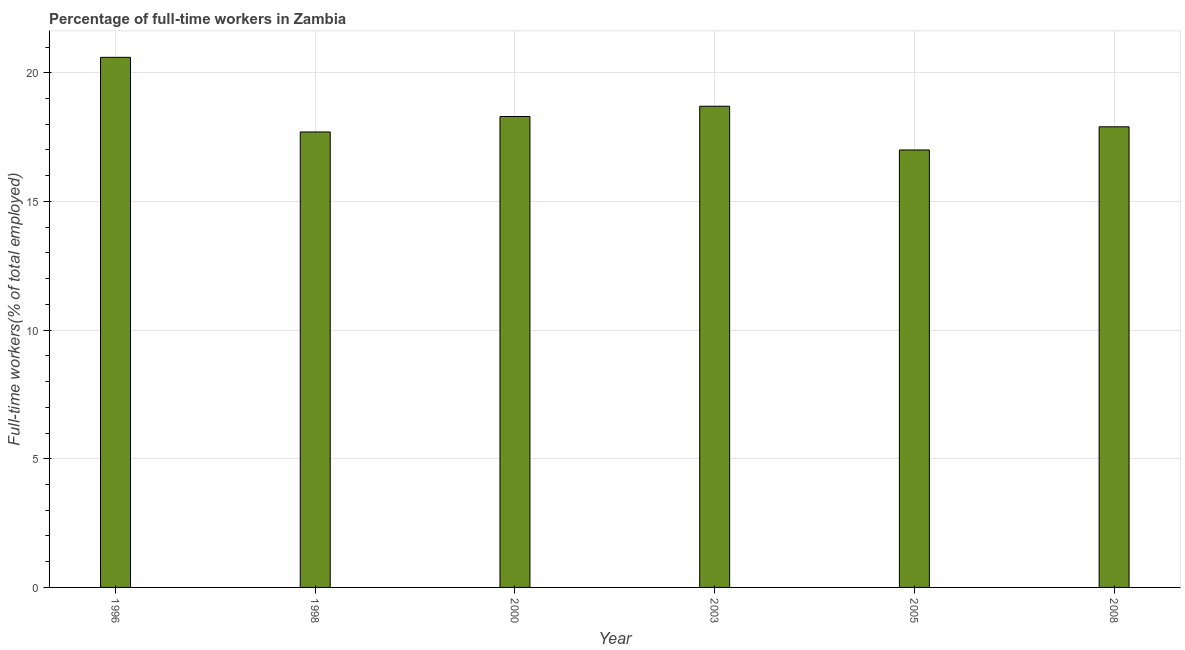Does the graph contain grids?
Ensure brevity in your answer.  Yes. What is the title of the graph?
Ensure brevity in your answer.  Percentage of full-time workers in Zambia. What is the label or title of the Y-axis?
Offer a terse response. Full-time workers(% of total employed). What is the percentage of full-time workers in 2000?
Your answer should be compact. 18.3. Across all years, what is the maximum percentage of full-time workers?
Give a very brief answer. 20.6. What is the sum of the percentage of full-time workers?
Provide a succinct answer. 110.2. What is the average percentage of full-time workers per year?
Offer a terse response. 18.37. What is the median percentage of full-time workers?
Make the answer very short. 18.1. Is the percentage of full-time workers in 1998 less than that in 2008?
Provide a succinct answer. Yes. Is the difference between the percentage of full-time workers in 1998 and 2005 greater than the difference between any two years?
Your response must be concise. No. What is the difference between the highest and the lowest percentage of full-time workers?
Ensure brevity in your answer.  3.6. How many years are there in the graph?
Ensure brevity in your answer.  6. What is the Full-time workers(% of total employed) of 1996?
Make the answer very short. 20.6. What is the Full-time workers(% of total employed) in 1998?
Your response must be concise. 17.7. What is the Full-time workers(% of total employed) in 2000?
Make the answer very short. 18.3. What is the Full-time workers(% of total employed) in 2003?
Provide a short and direct response. 18.7. What is the Full-time workers(% of total employed) of 2005?
Offer a very short reply. 17. What is the Full-time workers(% of total employed) in 2008?
Offer a very short reply. 17.9. What is the difference between the Full-time workers(% of total employed) in 1996 and 2000?
Provide a short and direct response. 2.3. What is the difference between the Full-time workers(% of total employed) in 1996 and 2008?
Make the answer very short. 2.7. What is the difference between the Full-time workers(% of total employed) in 1998 and 2000?
Provide a succinct answer. -0.6. What is the difference between the Full-time workers(% of total employed) in 1998 and 2003?
Provide a short and direct response. -1. What is the difference between the Full-time workers(% of total employed) in 1998 and 2005?
Provide a short and direct response. 0.7. What is the difference between the Full-time workers(% of total employed) in 2000 and 2003?
Give a very brief answer. -0.4. What is the difference between the Full-time workers(% of total employed) in 2000 and 2005?
Make the answer very short. 1.3. What is the difference between the Full-time workers(% of total employed) in 2005 and 2008?
Your response must be concise. -0.9. What is the ratio of the Full-time workers(% of total employed) in 1996 to that in 1998?
Ensure brevity in your answer.  1.16. What is the ratio of the Full-time workers(% of total employed) in 1996 to that in 2000?
Make the answer very short. 1.13. What is the ratio of the Full-time workers(% of total employed) in 1996 to that in 2003?
Provide a short and direct response. 1.1. What is the ratio of the Full-time workers(% of total employed) in 1996 to that in 2005?
Give a very brief answer. 1.21. What is the ratio of the Full-time workers(% of total employed) in 1996 to that in 2008?
Your answer should be compact. 1.15. What is the ratio of the Full-time workers(% of total employed) in 1998 to that in 2003?
Ensure brevity in your answer.  0.95. What is the ratio of the Full-time workers(% of total employed) in 1998 to that in 2005?
Give a very brief answer. 1.04. What is the ratio of the Full-time workers(% of total employed) in 1998 to that in 2008?
Your response must be concise. 0.99. What is the ratio of the Full-time workers(% of total employed) in 2000 to that in 2003?
Ensure brevity in your answer.  0.98. What is the ratio of the Full-time workers(% of total employed) in 2000 to that in 2005?
Your response must be concise. 1.08. What is the ratio of the Full-time workers(% of total employed) in 2000 to that in 2008?
Your answer should be very brief. 1.02. What is the ratio of the Full-time workers(% of total employed) in 2003 to that in 2005?
Provide a succinct answer. 1.1. What is the ratio of the Full-time workers(% of total employed) in 2003 to that in 2008?
Provide a short and direct response. 1.04. 